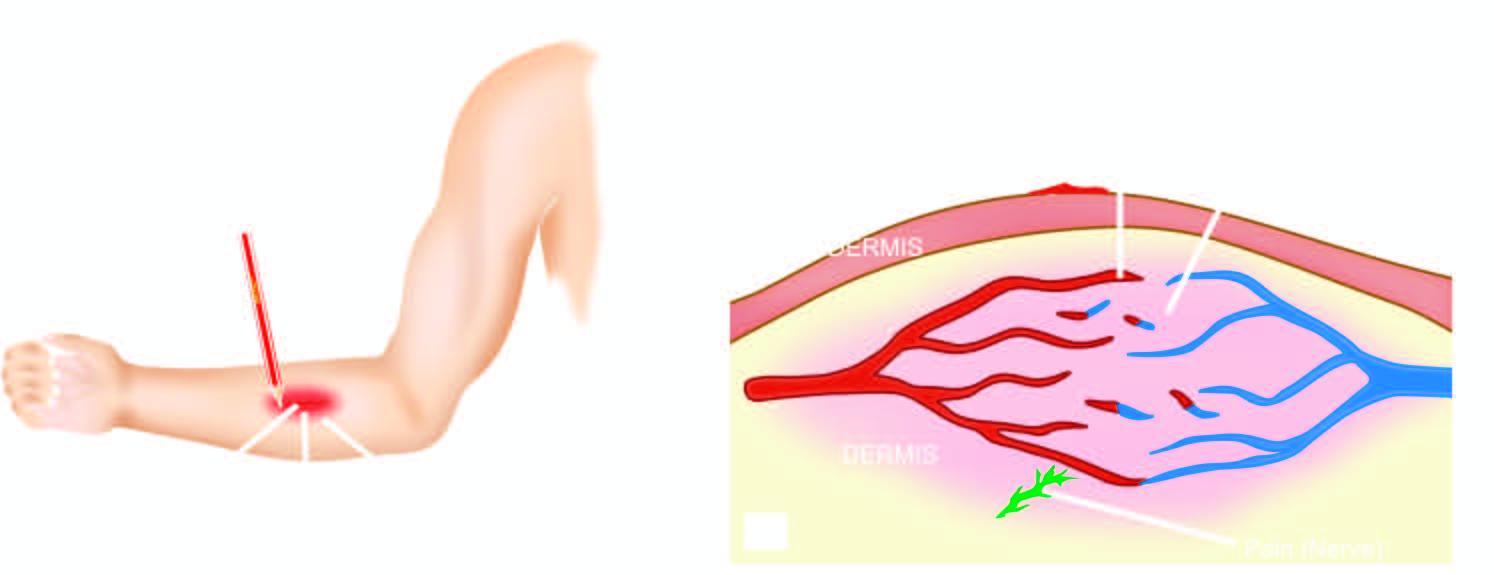what is 'triple response ' elicited by?
Answer the question using a single word or phrase. Firm stroking of skin of forearm with a pencil 